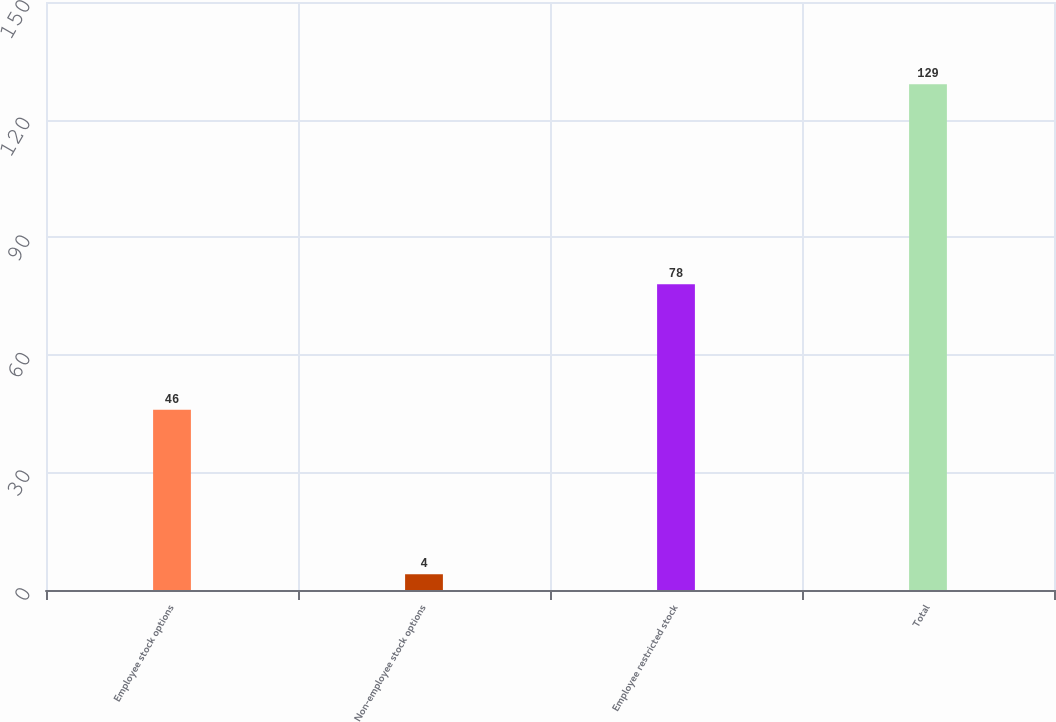Convert chart to OTSL. <chart><loc_0><loc_0><loc_500><loc_500><bar_chart><fcel>Employee stock options<fcel>Non-employee stock options<fcel>Employee restricted stock<fcel>Total<nl><fcel>46<fcel>4<fcel>78<fcel>129<nl></chart> 